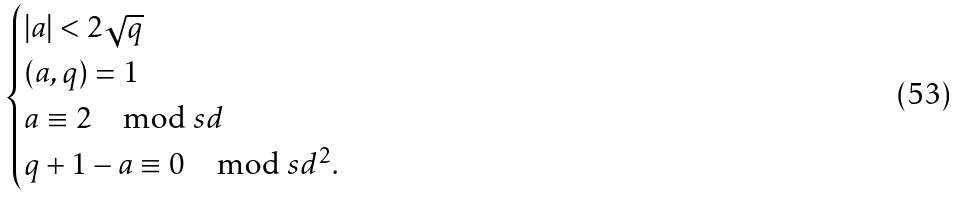<formula> <loc_0><loc_0><loc_500><loc_500>\begin{cases} | a | < 2 \sqrt { q } \\ ( a , q ) = 1 \\ a \equiv 2 \mod s { d } \\ q + 1 - a \equiv 0 \mod s { d ^ { 2 } } . \end{cases}</formula> 